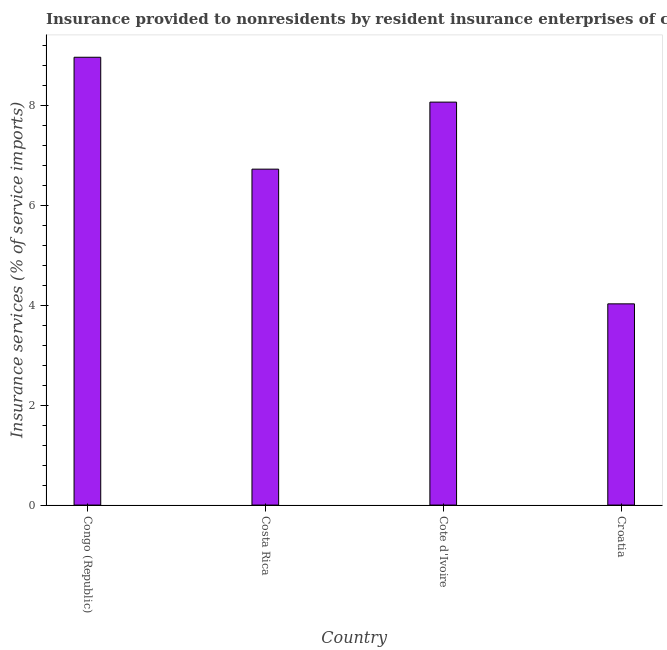What is the title of the graph?
Ensure brevity in your answer.  Insurance provided to nonresidents by resident insurance enterprises of countries in 2005. What is the label or title of the X-axis?
Your answer should be compact. Country. What is the label or title of the Y-axis?
Offer a very short reply. Insurance services (% of service imports). What is the insurance and financial services in Congo (Republic)?
Your answer should be compact. 8.96. Across all countries, what is the maximum insurance and financial services?
Ensure brevity in your answer.  8.96. Across all countries, what is the minimum insurance and financial services?
Ensure brevity in your answer.  4.03. In which country was the insurance and financial services maximum?
Give a very brief answer. Congo (Republic). In which country was the insurance and financial services minimum?
Keep it short and to the point. Croatia. What is the sum of the insurance and financial services?
Provide a succinct answer. 27.78. What is the difference between the insurance and financial services in Costa Rica and Croatia?
Give a very brief answer. 2.7. What is the average insurance and financial services per country?
Your response must be concise. 6.95. What is the median insurance and financial services?
Ensure brevity in your answer.  7.39. In how many countries, is the insurance and financial services greater than 2.8 %?
Your answer should be compact. 4. What is the ratio of the insurance and financial services in Cote d'Ivoire to that in Croatia?
Make the answer very short. 2. Is the insurance and financial services in Congo (Republic) less than that in Croatia?
Your answer should be very brief. No. Is the difference between the insurance and financial services in Cote d'Ivoire and Croatia greater than the difference between any two countries?
Give a very brief answer. No. What is the difference between the highest and the second highest insurance and financial services?
Your answer should be compact. 0.9. Is the sum of the insurance and financial services in Cote d'Ivoire and Croatia greater than the maximum insurance and financial services across all countries?
Your answer should be very brief. Yes. What is the difference between the highest and the lowest insurance and financial services?
Your answer should be very brief. 4.94. In how many countries, is the insurance and financial services greater than the average insurance and financial services taken over all countries?
Offer a very short reply. 2. Are the values on the major ticks of Y-axis written in scientific E-notation?
Your response must be concise. No. What is the Insurance services (% of service imports) in Congo (Republic)?
Your response must be concise. 8.96. What is the Insurance services (% of service imports) in Costa Rica?
Give a very brief answer. 6.72. What is the Insurance services (% of service imports) of Cote d'Ivoire?
Your answer should be compact. 8.07. What is the Insurance services (% of service imports) of Croatia?
Ensure brevity in your answer.  4.03. What is the difference between the Insurance services (% of service imports) in Congo (Republic) and Costa Rica?
Offer a very short reply. 2.24. What is the difference between the Insurance services (% of service imports) in Congo (Republic) and Cote d'Ivoire?
Your answer should be very brief. 0.9. What is the difference between the Insurance services (% of service imports) in Congo (Republic) and Croatia?
Ensure brevity in your answer.  4.94. What is the difference between the Insurance services (% of service imports) in Costa Rica and Cote d'Ivoire?
Your answer should be compact. -1.34. What is the difference between the Insurance services (% of service imports) in Costa Rica and Croatia?
Ensure brevity in your answer.  2.7. What is the difference between the Insurance services (% of service imports) in Cote d'Ivoire and Croatia?
Give a very brief answer. 4.04. What is the ratio of the Insurance services (% of service imports) in Congo (Republic) to that in Costa Rica?
Provide a succinct answer. 1.33. What is the ratio of the Insurance services (% of service imports) in Congo (Republic) to that in Cote d'Ivoire?
Your answer should be very brief. 1.11. What is the ratio of the Insurance services (% of service imports) in Congo (Republic) to that in Croatia?
Keep it short and to the point. 2.23. What is the ratio of the Insurance services (% of service imports) in Costa Rica to that in Cote d'Ivoire?
Offer a terse response. 0.83. What is the ratio of the Insurance services (% of service imports) in Costa Rica to that in Croatia?
Keep it short and to the point. 1.67. What is the ratio of the Insurance services (% of service imports) in Cote d'Ivoire to that in Croatia?
Keep it short and to the point. 2. 